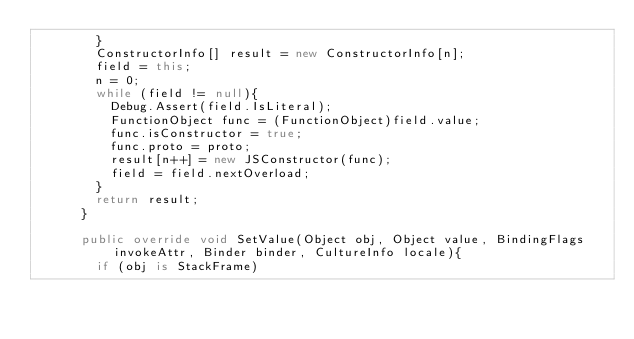Convert code to text. <code><loc_0><loc_0><loc_500><loc_500><_C#_>        }
        ConstructorInfo[] result = new ConstructorInfo[n];
        field = this;
        n = 0;
        while (field != null){
          Debug.Assert(field.IsLiteral);
          FunctionObject func = (FunctionObject)field.value;
          func.isConstructor = true;
          func.proto = proto;
          result[n++] = new JSConstructor(func);
          field = field.nextOverload;
        }
        return result;
      }
      
      public override void SetValue(Object obj, Object value, BindingFlags invokeAttr, Binder binder, CultureInfo locale){
        if (obj is StackFrame)</code> 